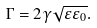<formula> <loc_0><loc_0><loc_500><loc_500>\Gamma = 2 \gamma \sqrt { \varepsilon \varepsilon _ { 0 } } .</formula> 